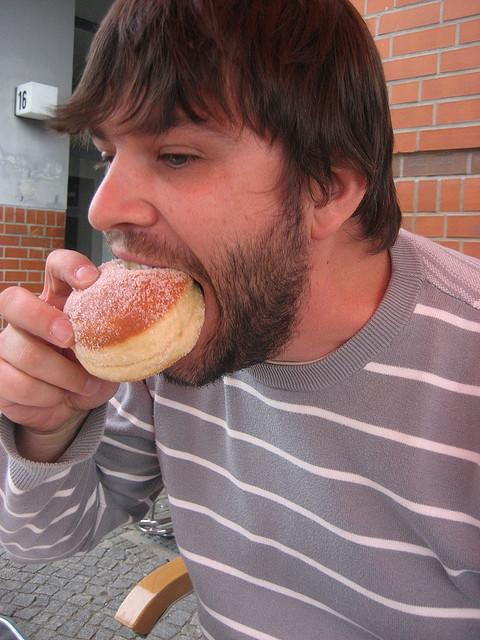Which character wears a shirt with a similar pattern to this man's shirt?

Choices:
A) peter pan
B) linus
C) donald duck
D) daffy duck linus 